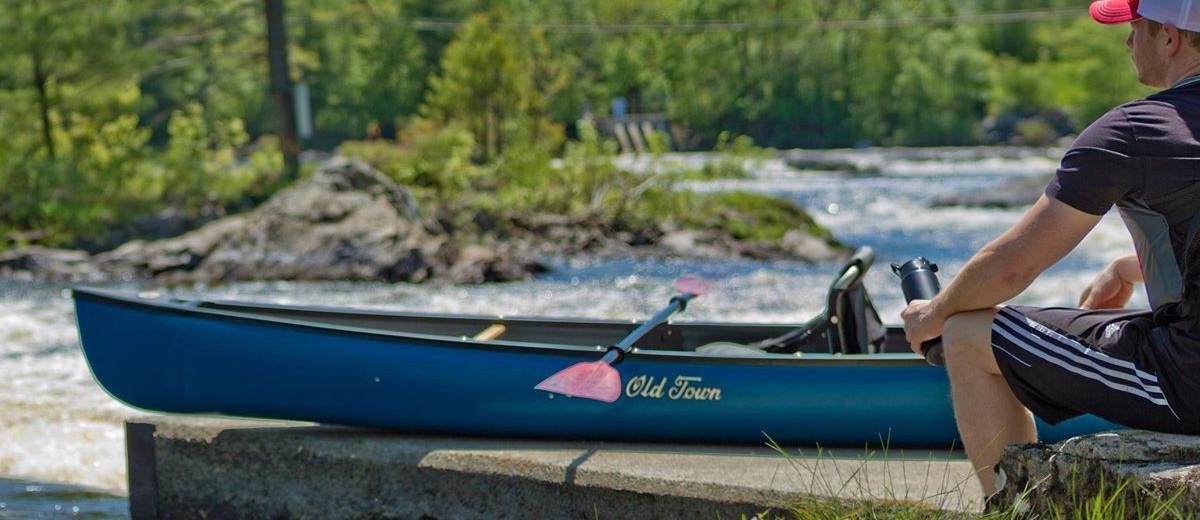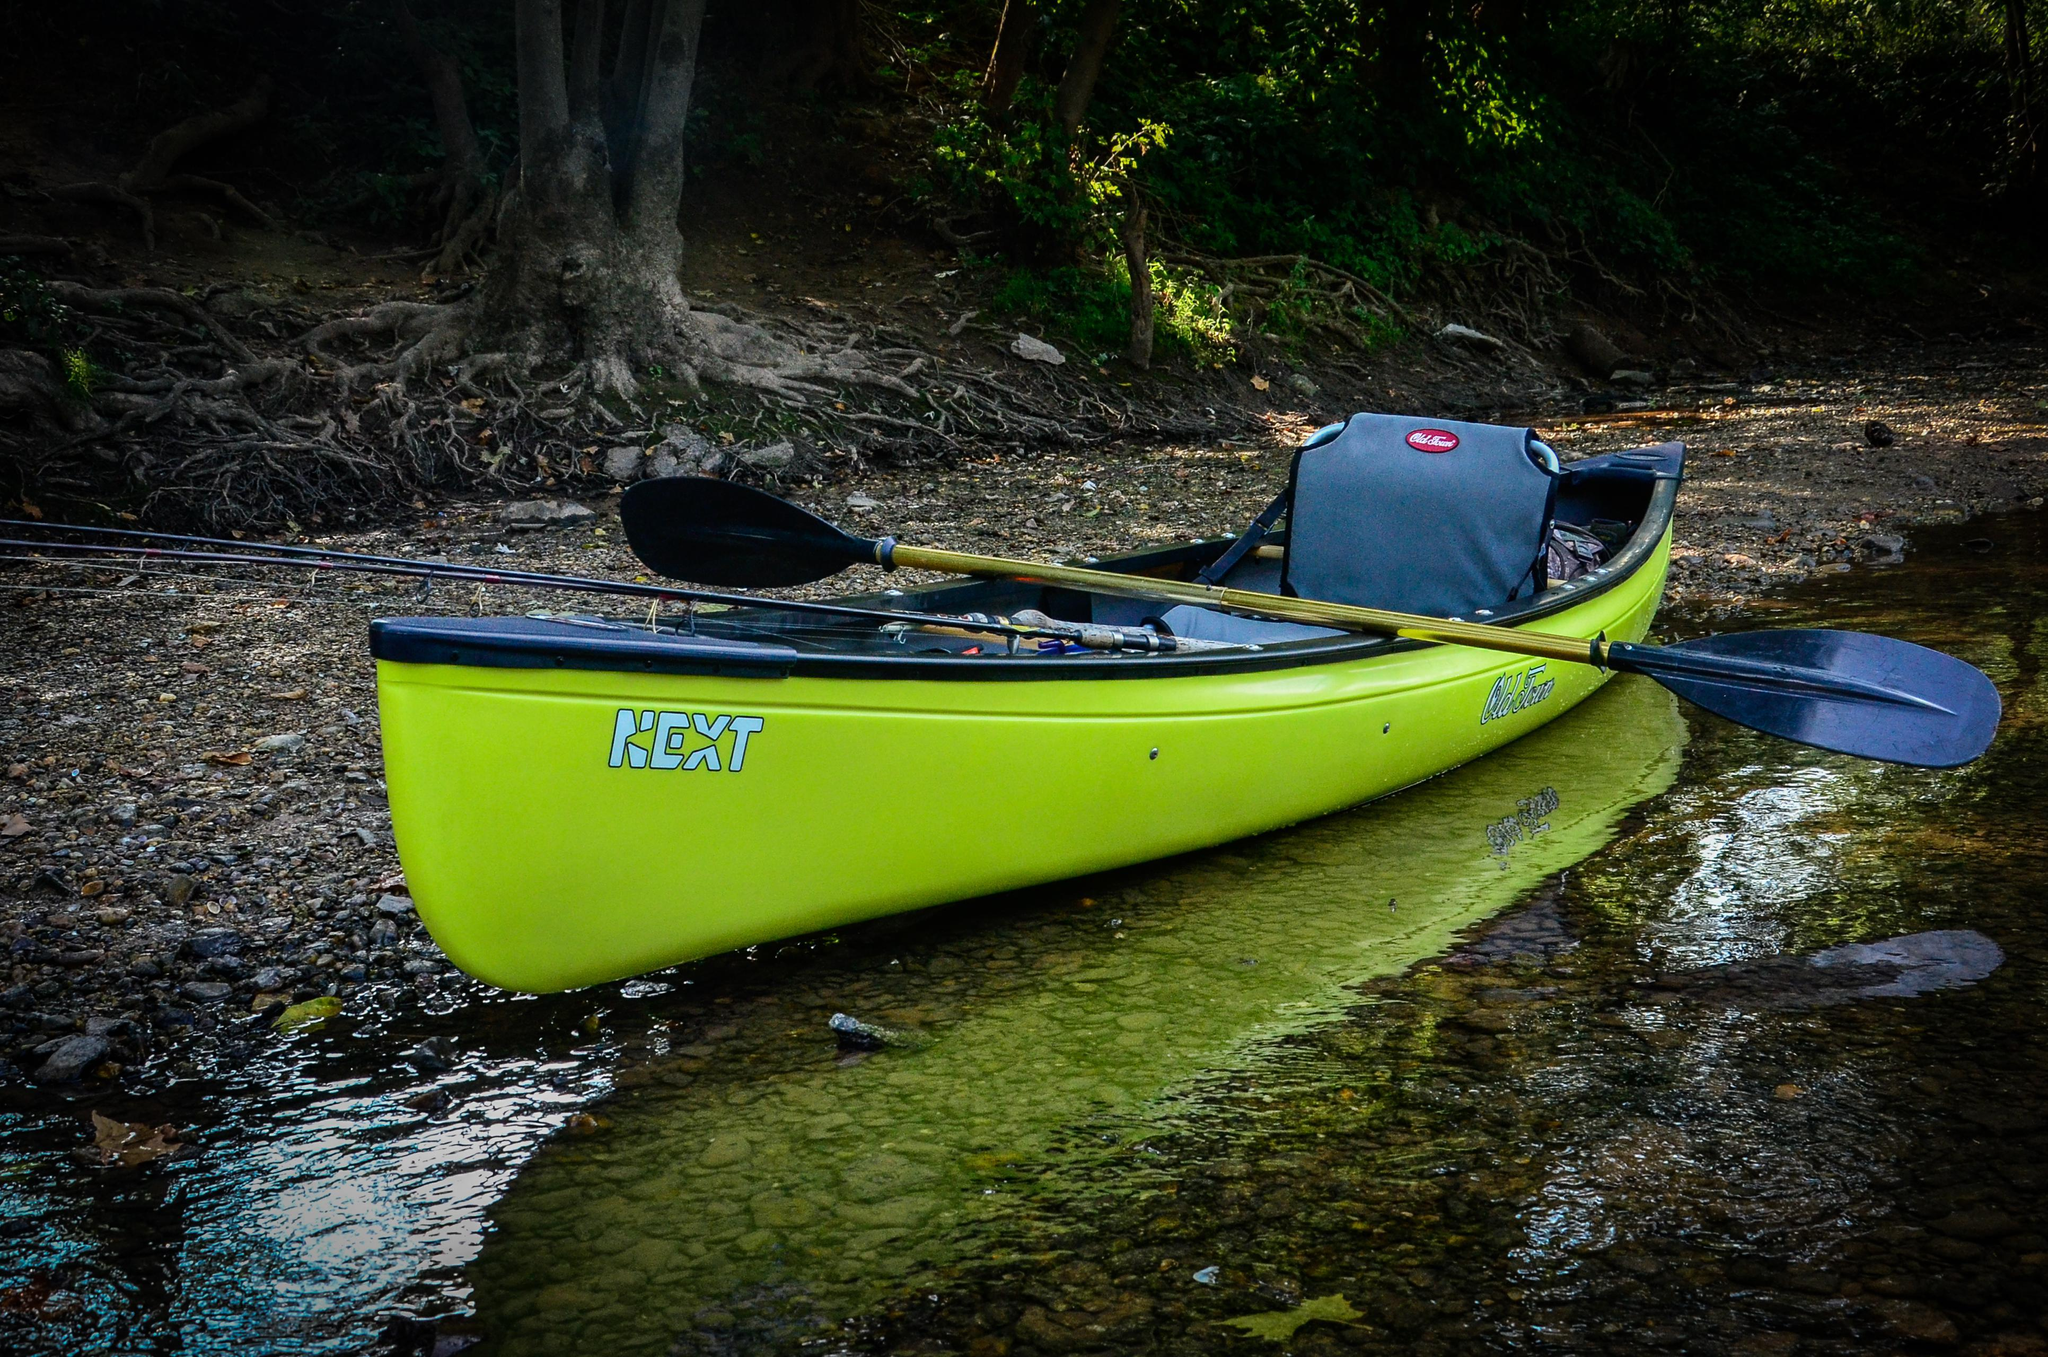The first image is the image on the left, the second image is the image on the right. Analyze the images presented: Is the assertion "In one image, a man in a canoe is holding an oar and wearing a life vest and hat." valid? Answer yes or no. No. The first image is the image on the left, the second image is the image on the right. Assess this claim about the two images: "A person is paddling a canoe diagonally to the left in the left image.". Correct or not? Answer yes or no. No. 